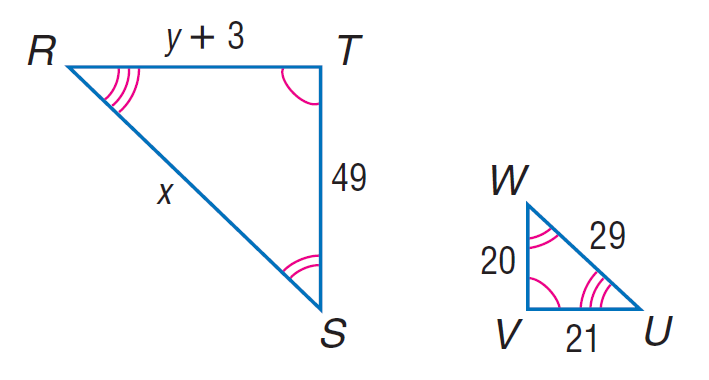Answer the mathemtical geometry problem and directly provide the correct option letter.
Question: Each pair of polygons is similar. Find x.
Choices: A: 29 B: 55.3 C: 71.05 D: 78 C 